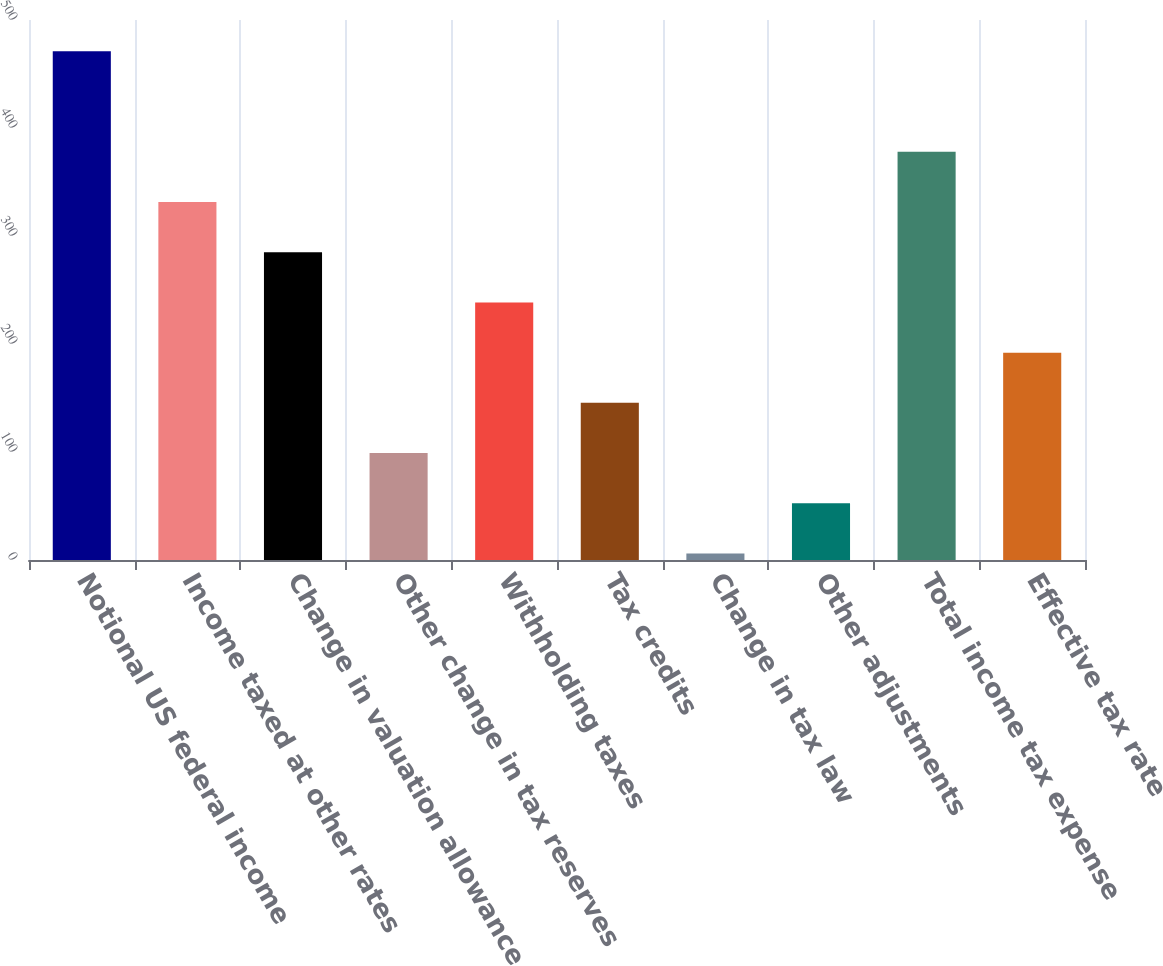Convert chart to OTSL. <chart><loc_0><loc_0><loc_500><loc_500><bar_chart><fcel>Notional US federal income<fcel>Income taxed at other rates<fcel>Change in valuation allowance<fcel>Other change in tax reserves<fcel>Withholding taxes<fcel>Tax credits<fcel>Change in tax law<fcel>Other adjustments<fcel>Total income tax expense<fcel>Effective tax rate<nl><fcel>471<fcel>331.5<fcel>285<fcel>99<fcel>238.5<fcel>145.5<fcel>6<fcel>52.5<fcel>378<fcel>192<nl></chart> 